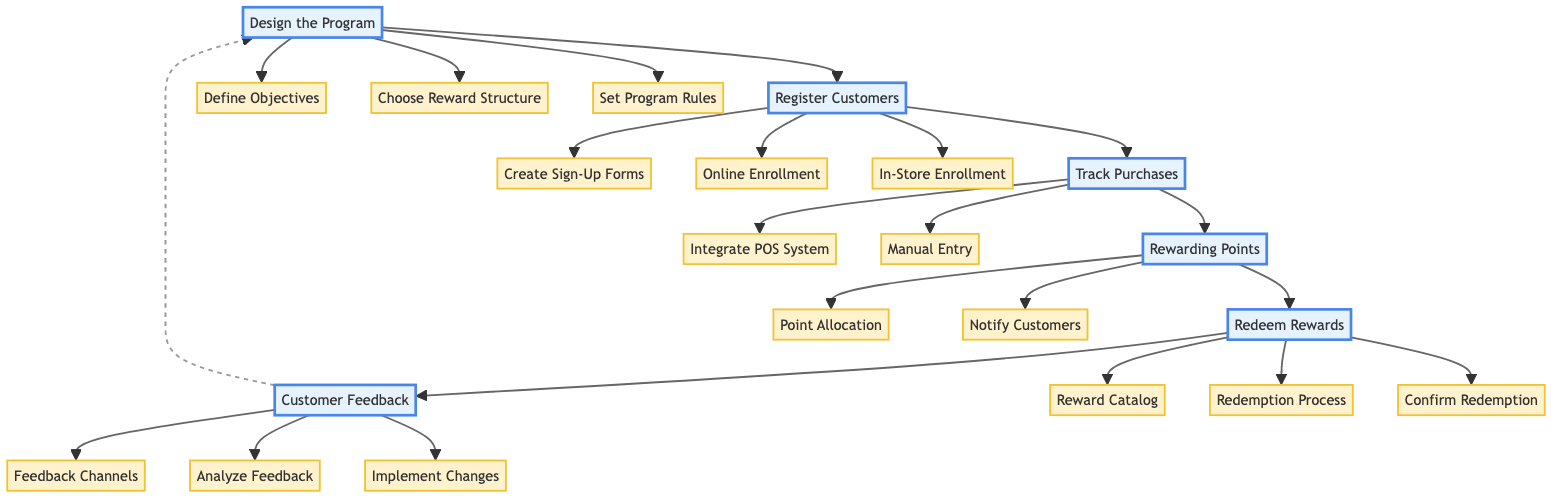What is the first step in the loyalty program implementation? The flowchart shows that the first step is "Design the Program," leading into subsequent steps.
Answer: Design the Program How many tasks are under "Register Customers"? There are three tasks listed under "Register Customers": Create Sign-Up Forms, Online Enrollment, and In-Store Enrollment.
Answer: 3 What is one way to notify customers about points earned? The chart indicates that one task is to "Send automatic notifications via email or app about points earned after each purchase."
Answer: Email or app Which two steps are directly connected? The flowchart shows that "Rewarding Points" is directly connected to both "Track Purchases" and "Redeem Rewards."
Answer: Rewarding Points and Track Purchases What task follows the "Rewarding Points" step? The flowchart outlines that "Redeem Rewards" is the next step after "Rewarding Points."
Answer: Redeem Rewards Which step allows for feedback collection? The "Customer Feedback" step includes tasks for setting up channels for customers to provide feedback on the loyalty program.
Answer: Customer Feedback How many tasks involve the redemption process? There are three tasks related to "Redeem Rewards": Reward Catalog, Redemption Process, and Confirm Redemption, which indicate actions for redemption.
Answer: 3 What is a prerequisite for "Track Purchases"? The prerequisite is that you must first complete the "Register Customers" step before you can track purchases.
Answer: Register Customers What can be redeemed according to the "Reward Catalog"? The "Reward Catalog" includes discounts, free books, or special events, as stated in the flowchart.
Answer: Discounts, free books, or special events 